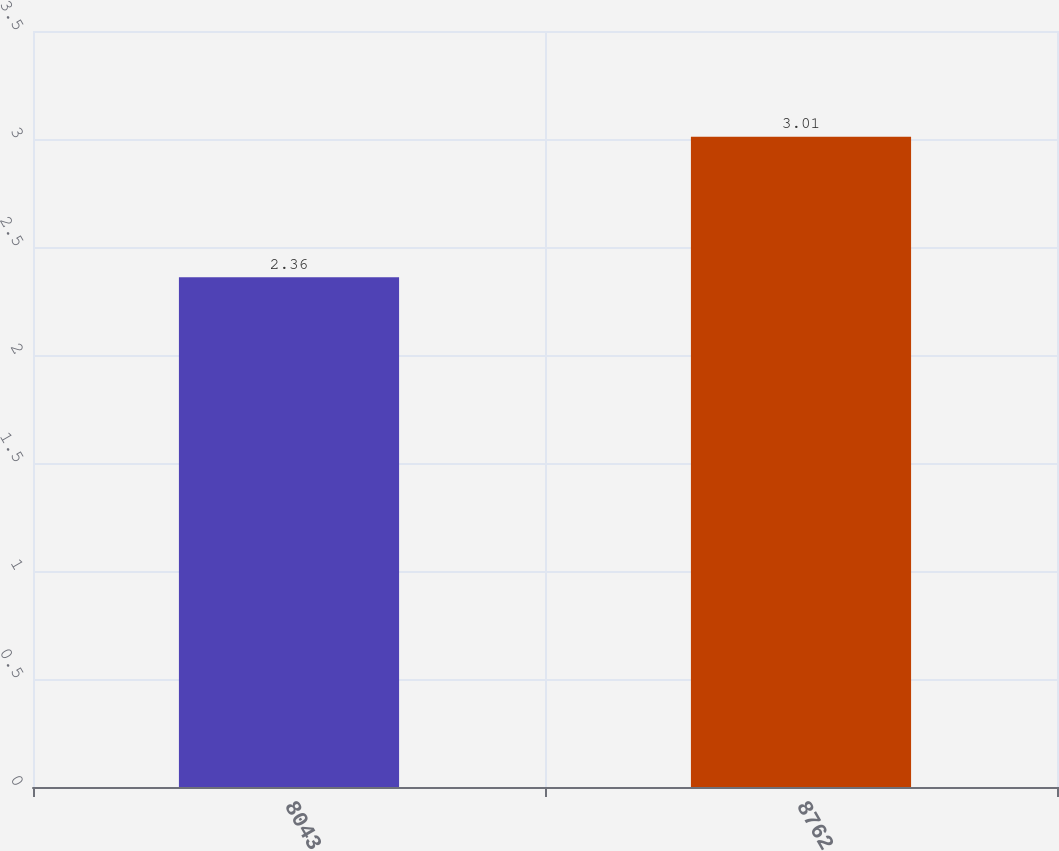Convert chart. <chart><loc_0><loc_0><loc_500><loc_500><bar_chart><fcel>8043<fcel>8762<nl><fcel>2.36<fcel>3.01<nl></chart> 